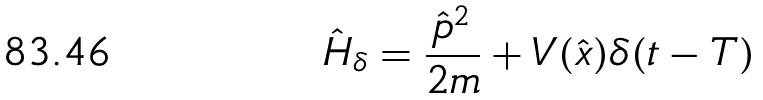Convert formula to latex. <formula><loc_0><loc_0><loc_500><loc_500>\hat { H } _ { \delta } = \frac { \hat { p } ^ { 2 } } { 2 m } + V ( \hat { x } ) \delta ( t - T )</formula> 